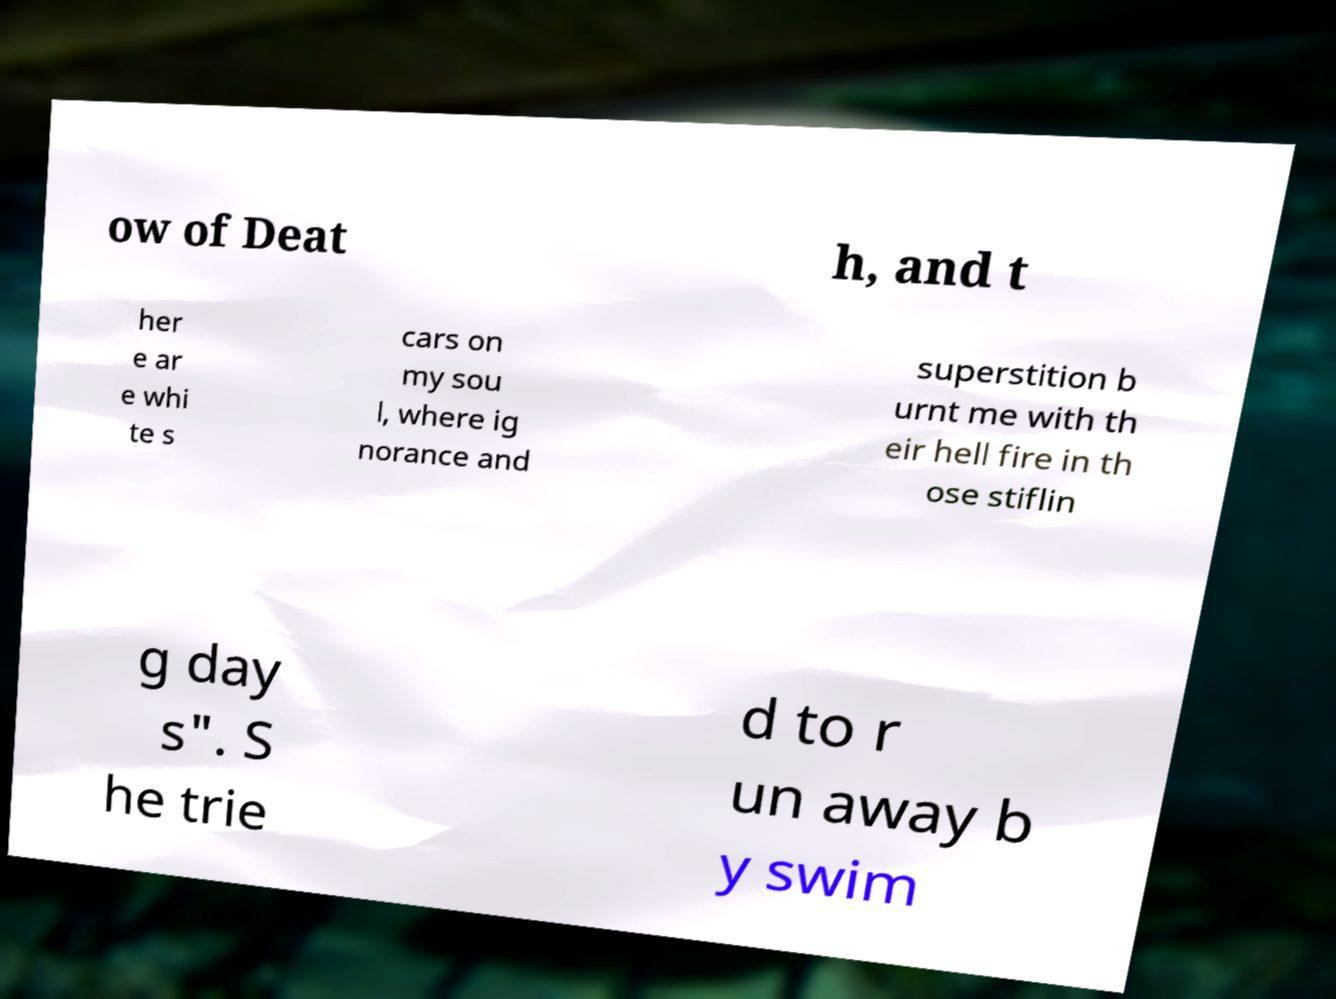Could you extract and type out the text from this image? ow of Deat h, and t her e ar e whi te s cars on my sou l, where ig norance and superstition b urnt me with th eir hell fire in th ose stiflin g day s". S he trie d to r un away b y swim 